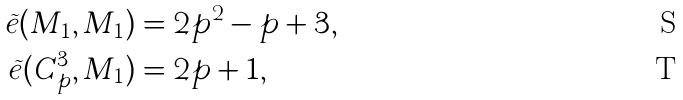<formula> <loc_0><loc_0><loc_500><loc_500>\widetilde { e } ( M _ { 1 } , M _ { 1 } ) & = 2 p ^ { 2 } - p + 3 , \\ \widetilde { e } ( C _ { p } ^ { 3 } , M _ { 1 } ) & = 2 p + 1 ,</formula> 